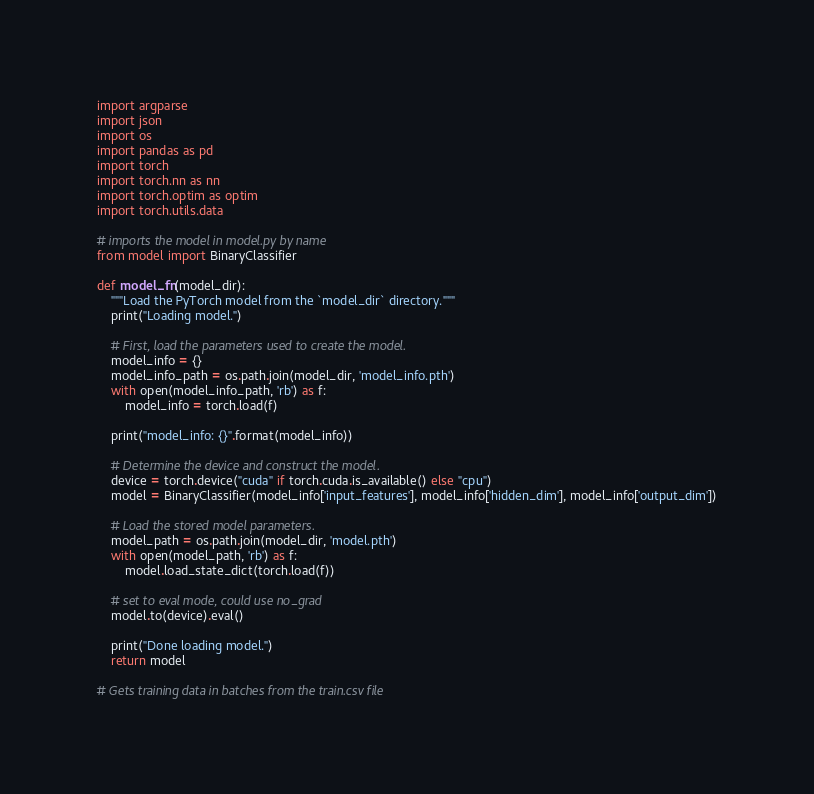<code> <loc_0><loc_0><loc_500><loc_500><_Python_>import argparse
import json
import os
import pandas as pd
import torch
import torch.nn as nn
import torch.optim as optim
import torch.utils.data

# imports the model in model.py by name
from model import BinaryClassifier

def model_fn(model_dir):
    """Load the PyTorch model from the `model_dir` directory."""
    print("Loading model.")

    # First, load the parameters used to create the model.
    model_info = {}
    model_info_path = os.path.join(model_dir, 'model_info.pth')
    with open(model_info_path, 'rb') as f:
        model_info = torch.load(f)

    print("model_info: {}".format(model_info))

    # Determine the device and construct the model.
    device = torch.device("cuda" if torch.cuda.is_available() else "cpu")
    model = BinaryClassifier(model_info['input_features'], model_info['hidden_dim'], model_info['output_dim'])

    # Load the stored model parameters.
    model_path = os.path.join(model_dir, 'model.pth')
    with open(model_path, 'rb') as f:
        model.load_state_dict(torch.load(f))

    # set to eval mode, could use no_grad
    model.to(device).eval()

    print("Done loading model.")
    return model

# Gets training data in batches from the train.csv file</code> 